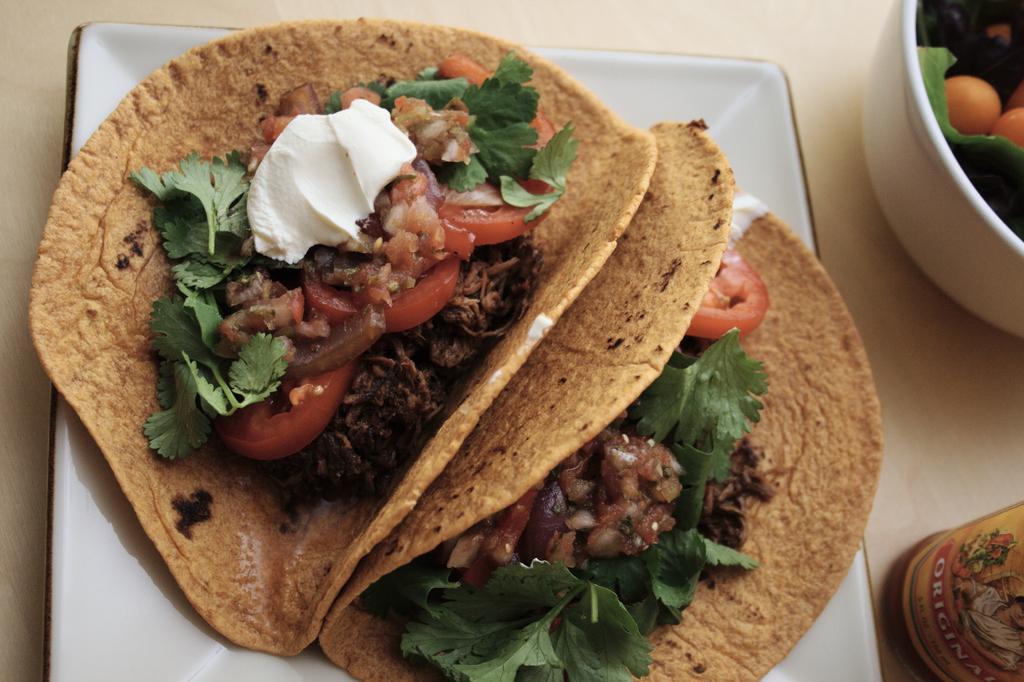Can you describe this image briefly? In this image we can see one white plate with food, one white bowl with food and one bottle on the surface looks like a table. There is one sticker with text and image on the bottle. 